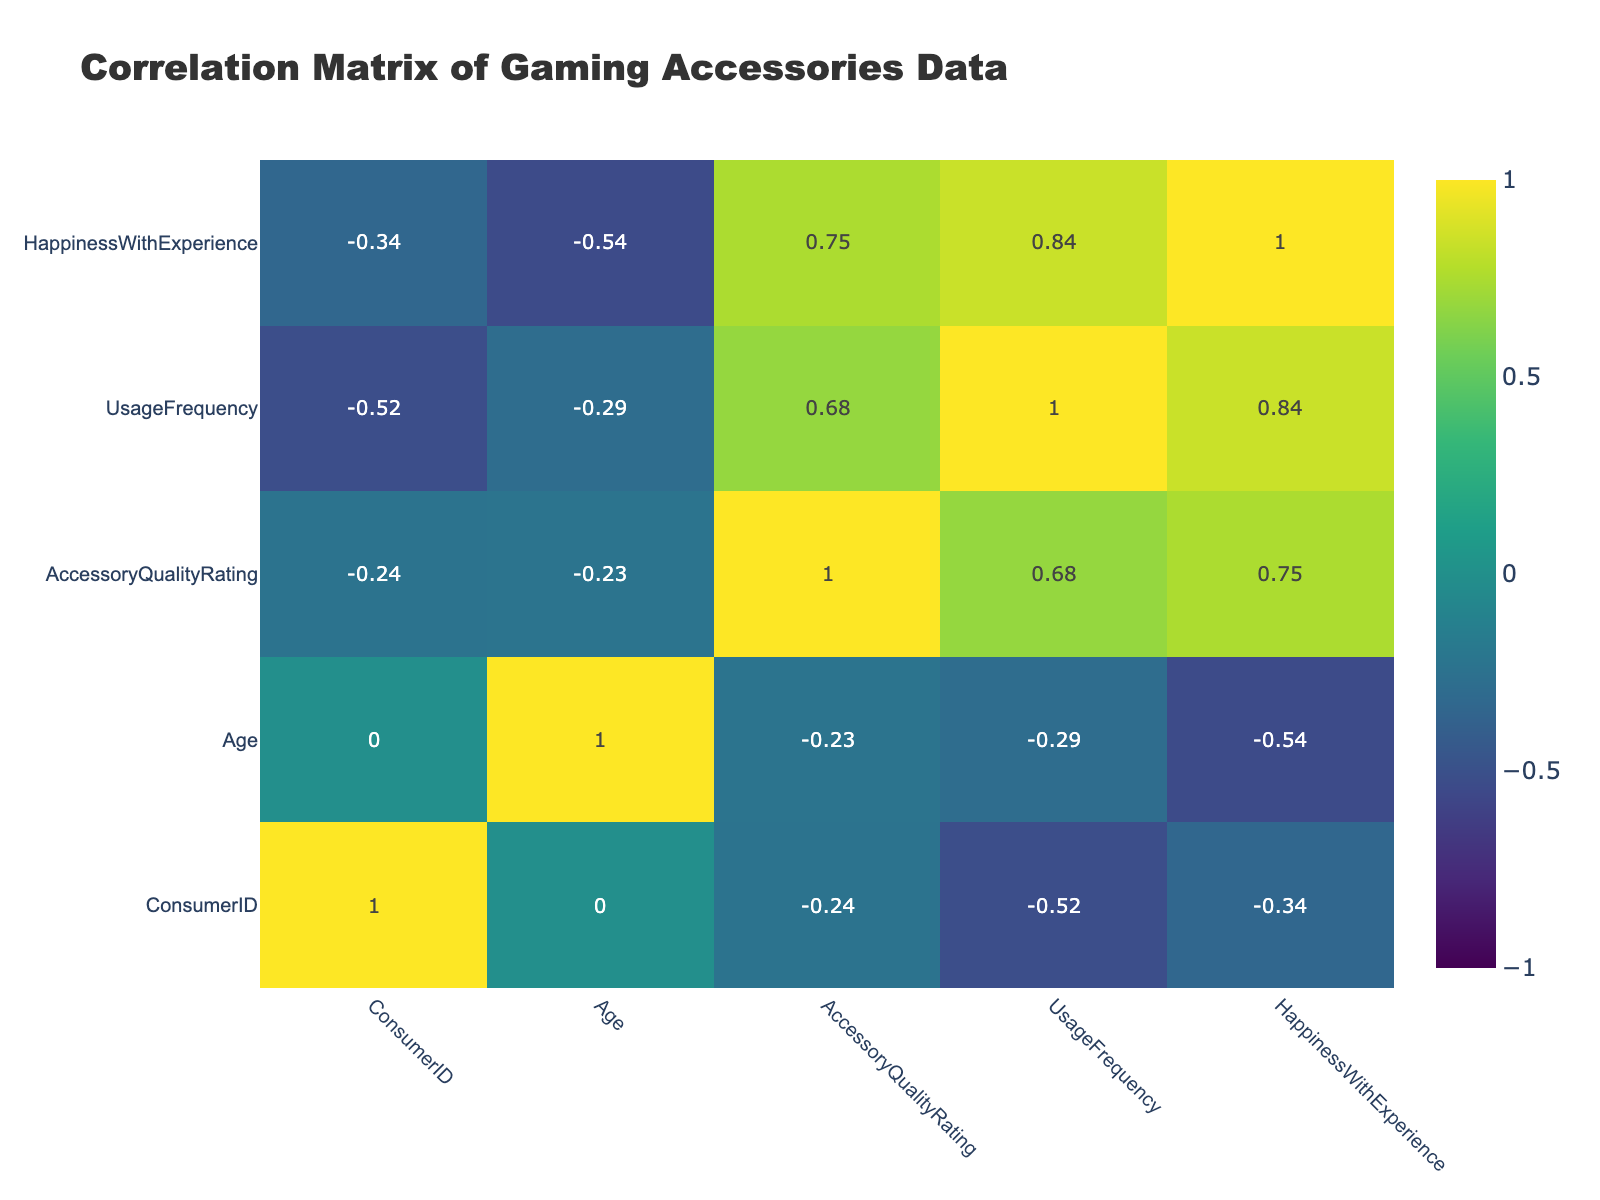What's the correlation between Accessory Quality Rating and Happiness With Experience? The table shows the values in the correlation matrix. By looking at the specific row of Accessory Quality Rating and the column of Happiness With Experience, we can see the correlation value is 0.72.
Answer: 0.72 What is the highest Accessory Quality Rating? To find the highest Accessory Quality Rating, we look through the Accessory Quality Rating values (9, 8, 7, 9, 6, 7, 8, 9, 6, 8). The maximum value is 9, which appears more than once (for Mechanical Keyboard, Gaming Mouse, and USB Microphone).
Answer: 9 Is there a significant relationship between Usage Frequency and Happiness With Experience? The correlation value between Usage Frequency and Happiness With Experience in the correlation matrix indicates this relationship. Upon inspection, this value is 0.53, suggesting a moderate positive relationship.
Answer: Yes What is the average Accessory Quality Rating among consumers under 30 years old? We first filter the data for consumers under 30, which includes Consumer ID 3, 4, 5, 6, 7, and calculate the average of their Accessory Quality Ratings (7, 9, 6, 7, 8) = (7 + 9 + 6 + 7 + 8) / 5 = 37 / 5 = 7.4.
Answer: 7.4 Which accessory has the lowest Happiness With Experience rating? Looking at the Happiness With Experience values (8, 7, 9, 10, 6, 7, 8, 9, 5, 7), we identify the lowest value is 5, corresponding to the Controller Charging Dock.
Answer: Controller Charging Dock How does the average Happiness With Experience compare between the consumers who use their accessories frequently (usage frequency of 5 or more) versus those who use them less often? We separate the consumers into two groups based on usage frequency: high usage (5, 5, 6, 5, 4), which gives an average of (9 + 9 + 10 + 9 + 8) = 45 / 5 = 9; lower usage (4, 2, 3, 3, 2) gives (7 + 6 + 7 + 5 + 7) = 32 / 5 = 6.4. The average happiness of high users is significantly higher.
Answer: High users have an average of 9, low users 6.4 Is using a VR headset associated with higher Accessory Quality Ratings? We find the Accessory Quality Rating for the VR Headset is 6. Taking the average of Accessory Quality Ratings for other accessories (9, 8, 7, 9, 8, 9, 6, 8) gives us (9 + 8 + 7 + 9 + 8 + 9 + 6 + 8) = 64 / 8 = 8, which is higher than 6.
Answer: No What trends can be observed regarding age and preferred accessories? By analyzing the ages and their corresponding preferred accessories, we notice younger consumers tend to prefer items like the Xbox Controller, while older consumers favor items such as VR Headset and Gaming Mouse. This indicates that preference varies with age.
Answer: Younger prefer gaming peripherals, older prefer advanced accessories What is the median usage frequency for all consumers? To find the median, we organize the usage frequencies (5, 4, 5, 6, 2, 3, 4, 5, 3, 2) in order: 2, 2, 3, 3, 4, 4, 5, 5, 5, 6, which gives a median of (4 + 5) / 2 = 4.5 as there are 10 data points.
Answer: 4.5 